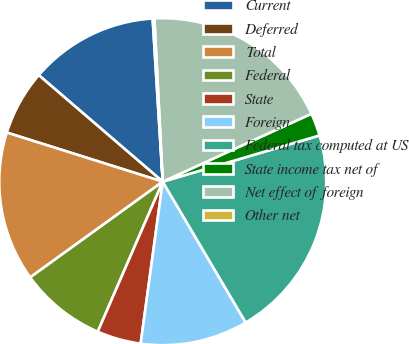Convert chart to OTSL. <chart><loc_0><loc_0><loc_500><loc_500><pie_chart><fcel>Current<fcel>Deferred<fcel>Total<fcel>Federal<fcel>State<fcel>Foreign<fcel>Federal tax computed at US<fcel>State income tax net of<fcel>Net effect of foreign<fcel>Other net<nl><fcel>12.72%<fcel>6.44%<fcel>14.81%<fcel>8.54%<fcel>4.35%<fcel>10.63%<fcel>21.09%<fcel>2.26%<fcel>18.99%<fcel>0.17%<nl></chart> 